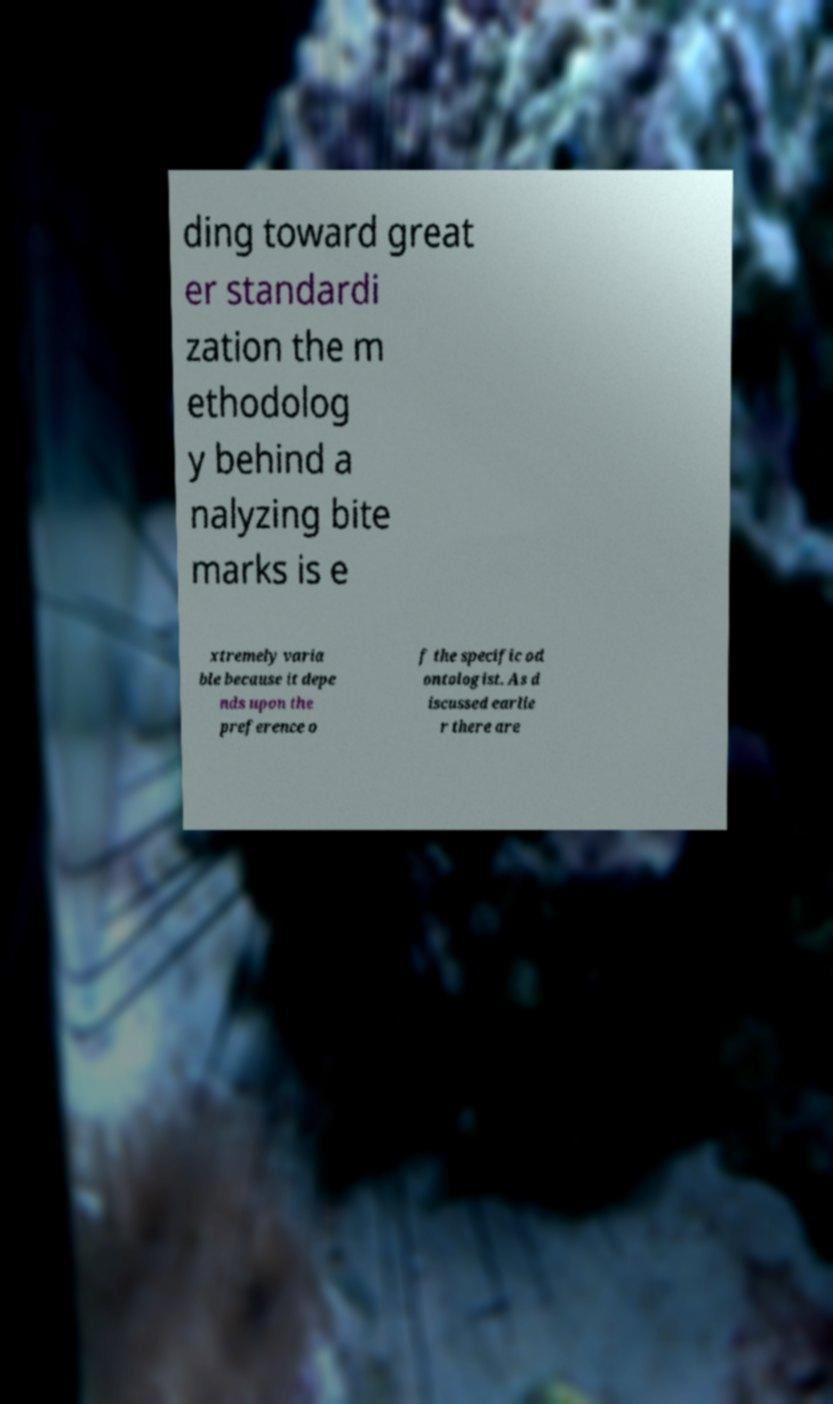Could you assist in decoding the text presented in this image and type it out clearly? ding toward great er standardi zation the m ethodolog y behind a nalyzing bite marks is e xtremely varia ble because it depe nds upon the preference o f the specific od ontologist. As d iscussed earlie r there are 